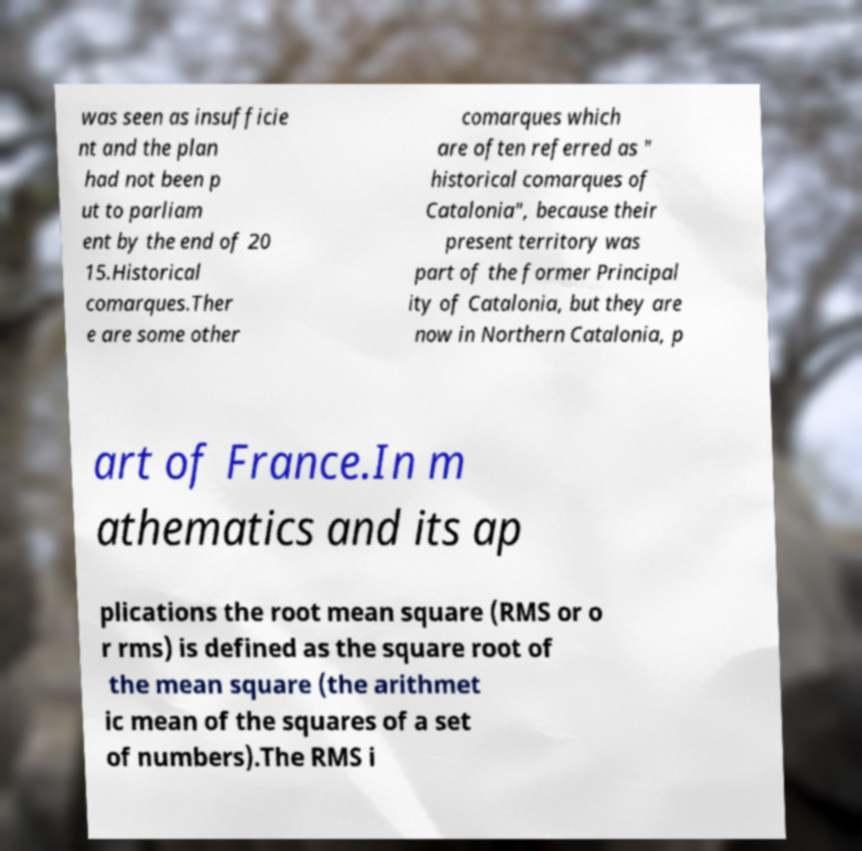Could you extract and type out the text from this image? was seen as insufficie nt and the plan had not been p ut to parliam ent by the end of 20 15.Historical comarques.Ther e are some other comarques which are often referred as " historical comarques of Catalonia", because their present territory was part of the former Principal ity of Catalonia, but they are now in Northern Catalonia, p art of France.In m athematics and its ap plications the root mean square (RMS or o r rms) is defined as the square root of the mean square (the arithmet ic mean of the squares of a set of numbers).The RMS i 